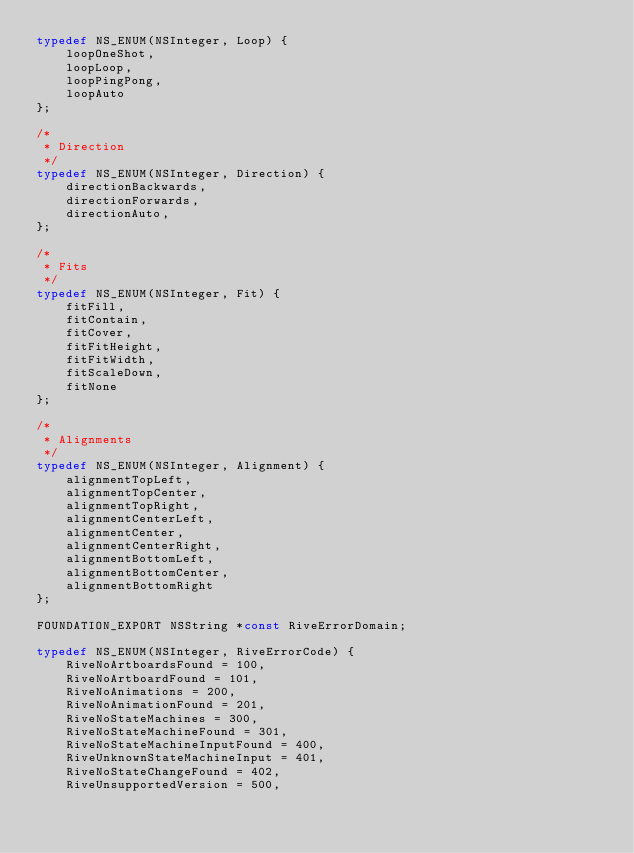<code> <loc_0><loc_0><loc_500><loc_500><_C_>typedef NS_ENUM(NSInteger, Loop) {
    loopOneShot,
    loopLoop,
    loopPingPong,
    loopAuto
};

/*
 * Direction
 */
typedef NS_ENUM(NSInteger, Direction) {
    directionBackwards,
    directionForwards,
    directionAuto,
};

/*
 * Fits
 */
typedef NS_ENUM(NSInteger, Fit) {
    fitFill,
    fitContain,
    fitCover,
    fitFitHeight,
    fitFitWidth,
    fitScaleDown,
    fitNone
};

/*
 * Alignments
 */
typedef NS_ENUM(NSInteger, Alignment) {
    alignmentTopLeft,
    alignmentTopCenter,
    alignmentTopRight,
    alignmentCenterLeft,
    alignmentCenter,
    alignmentCenterRight,
    alignmentBottomLeft,
    alignmentBottomCenter,
    alignmentBottomRight
};

FOUNDATION_EXPORT NSString *const RiveErrorDomain;

typedef NS_ENUM(NSInteger, RiveErrorCode) {
    RiveNoArtboardsFound = 100,
    RiveNoArtboardFound = 101,
    RiveNoAnimations = 200,
    RiveNoAnimationFound = 201,
    RiveNoStateMachines = 300,
    RiveNoStateMachineFound = 301,
    RiveNoStateMachineInputFound = 400,
    RiveUnknownStateMachineInput = 401,
    RiveNoStateChangeFound = 402,
    RiveUnsupportedVersion = 500,</code> 